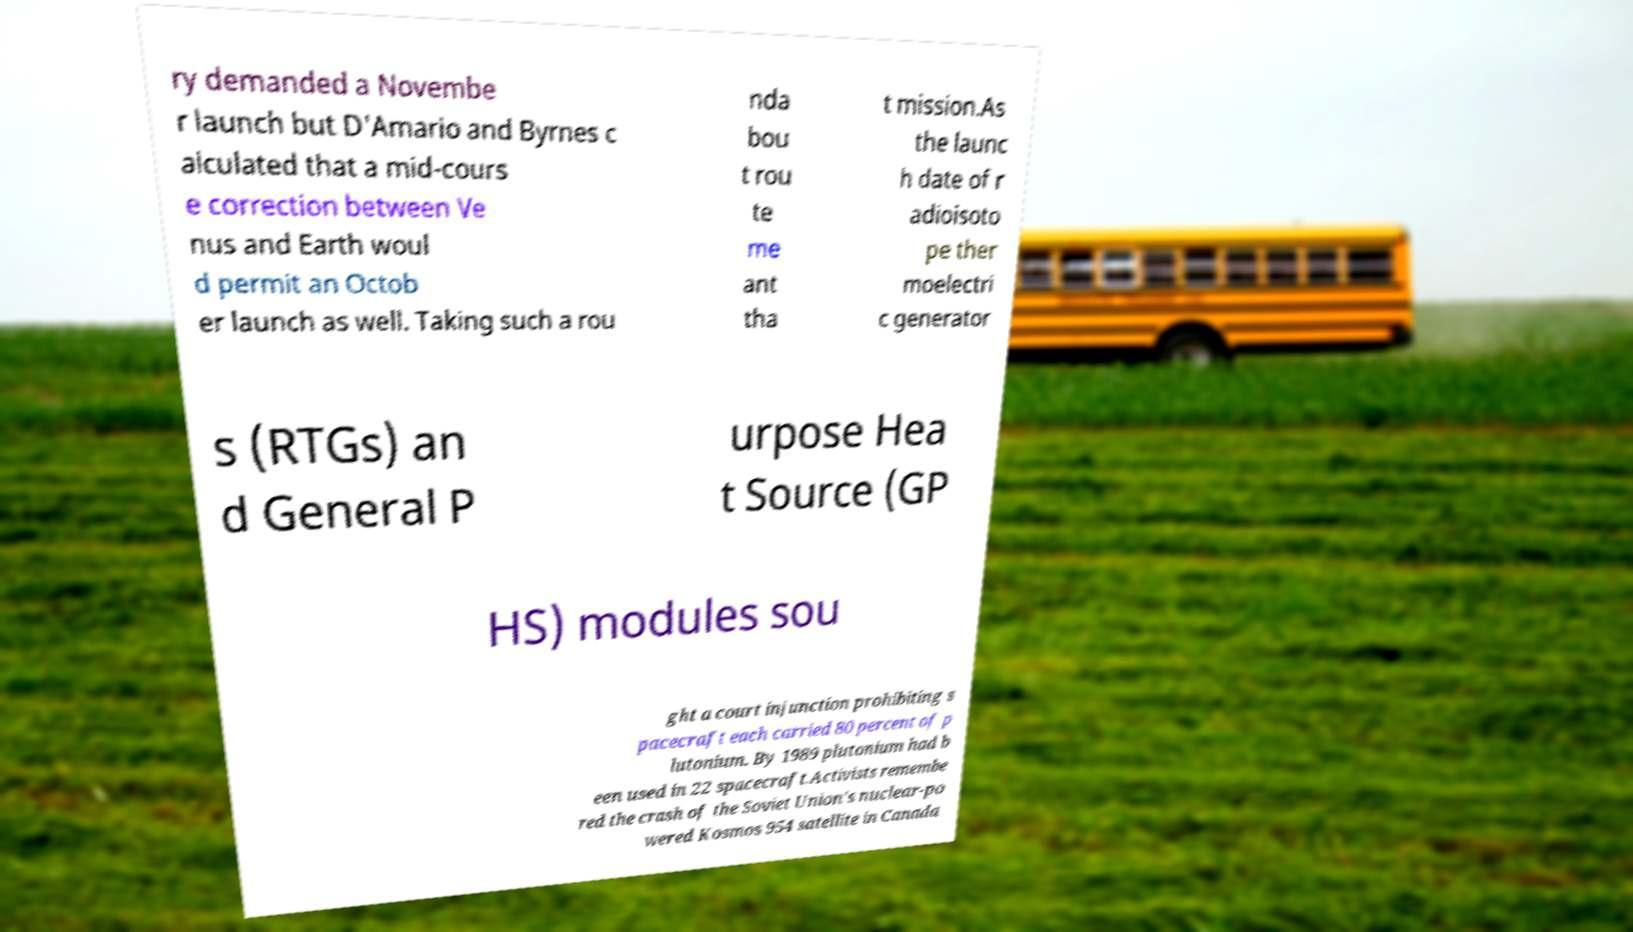I need the written content from this picture converted into text. Can you do that? ry demanded a Novembe r launch but D'Amario and Byrnes c alculated that a mid-cours e correction between Ve nus and Earth woul d permit an Octob er launch as well. Taking such a rou nda bou t rou te me ant tha t mission.As the launc h date of r adioisoto pe ther moelectri c generator s (RTGs) an d General P urpose Hea t Source (GP HS) modules sou ght a court injunction prohibiting s pacecraft each carried 80 percent of p lutonium. By 1989 plutonium had b een used in 22 spacecraft.Activists remembe red the crash of the Soviet Union's nuclear-po wered Kosmos 954 satellite in Canada 